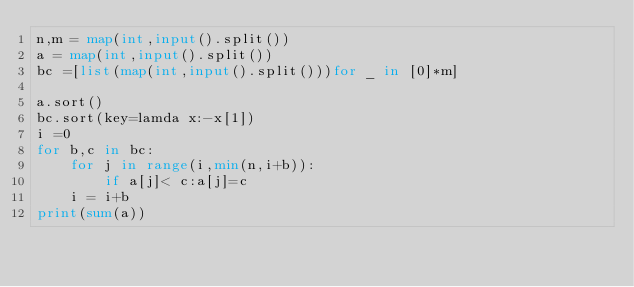<code> <loc_0><loc_0><loc_500><loc_500><_Python_>n,m = map(int,input().split())
a = map(int,input().split())
bc =[list(map(int,input().split()))for _ in [0]*m]

a.sort()
bc.sort(key=lamda x:-x[1])
i =0
for b,c in bc:
    for j in range(i,min(n,i+b)):
        if a[j]< c:a[j]=c
    i = i+b
print(sum(a))</code> 